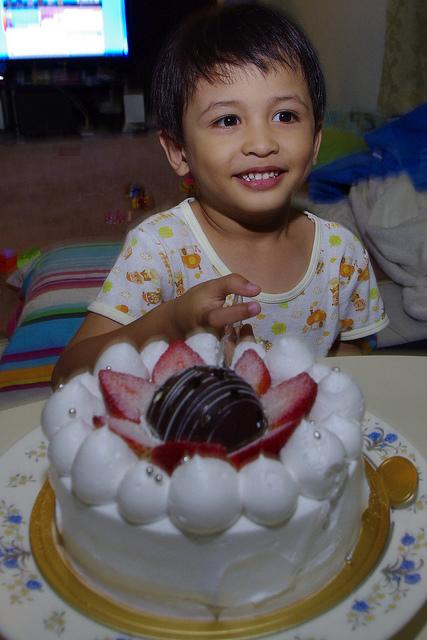Does the child look happy?
Be succinct. Yes. What type of event is this cake for?
Concise answer only. Birthday. What color is the floor?
Write a very short answer. Pink. What is this cake for?
Quick response, please. Birthday. Is this a marzipan cake?
Be succinct. No. If you cut the cake, what color will the inside be?
Give a very brief answer. White. Is this cake sloppily decorated?
Concise answer only. No. How many kids are there?
Answer briefly. 1. What color is the flower on the shirt?
Answer briefly. Orange. What fruit is on top of the cake?
Short answer required. Strawberries. Is the desert in the foreground melting?
Answer briefly. No. 